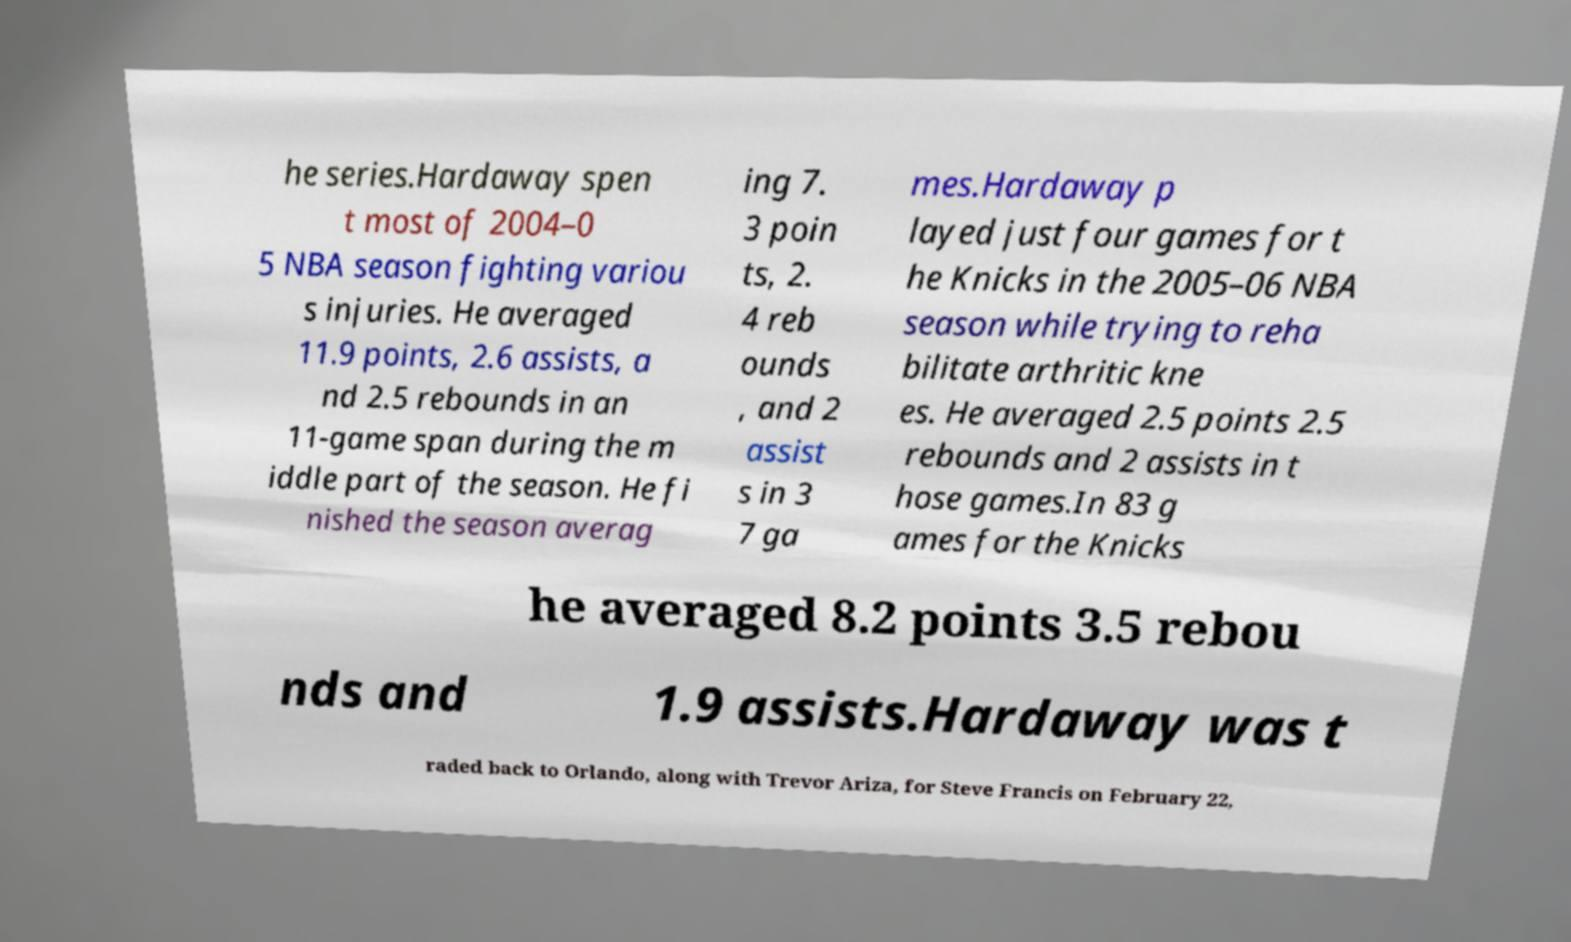Please identify and transcribe the text found in this image. he series.Hardaway spen t most of 2004–0 5 NBA season fighting variou s injuries. He averaged 11.9 points, 2.6 assists, a nd 2.5 rebounds in an 11-game span during the m iddle part of the season. He fi nished the season averag ing 7. 3 poin ts, 2. 4 reb ounds , and 2 assist s in 3 7 ga mes.Hardaway p layed just four games for t he Knicks in the 2005–06 NBA season while trying to reha bilitate arthritic kne es. He averaged 2.5 points 2.5 rebounds and 2 assists in t hose games.In 83 g ames for the Knicks he averaged 8.2 points 3.5 rebou nds and 1.9 assists.Hardaway was t raded back to Orlando, along with Trevor Ariza, for Steve Francis on February 22, 